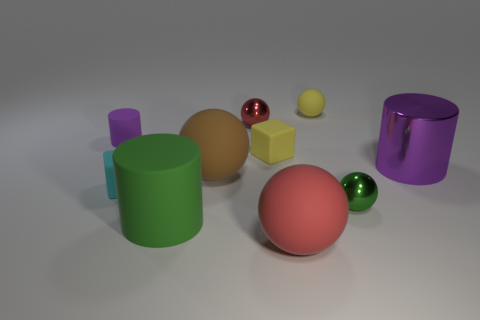Subtract all big brown balls. How many balls are left? 4 Subtract all green spheres. How many spheres are left? 4 Subtract all purple spheres. Subtract all brown blocks. How many spheres are left? 5 Subtract all blocks. How many objects are left? 8 Subtract all green rubber cylinders. Subtract all small red spheres. How many objects are left? 8 Add 1 red objects. How many red objects are left? 3 Add 4 red shiny spheres. How many red shiny spheres exist? 5 Subtract 0 purple spheres. How many objects are left? 10 